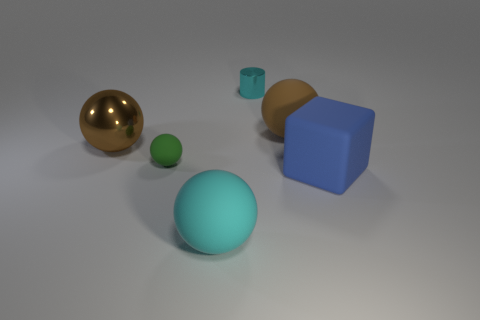Subtract all matte balls. How many balls are left? 1 Subtract all green balls. How many balls are left? 3 Subtract 2 spheres. How many spheres are left? 2 Add 4 large brown objects. How many objects exist? 10 Subtract all green cylinders. How many gray spheres are left? 0 Subtract all tiny brown rubber spheres. Subtract all shiny spheres. How many objects are left? 5 Add 2 rubber balls. How many rubber balls are left? 5 Add 2 cyan rubber objects. How many cyan rubber objects exist? 3 Subtract 0 purple spheres. How many objects are left? 6 Subtract all cubes. How many objects are left? 5 